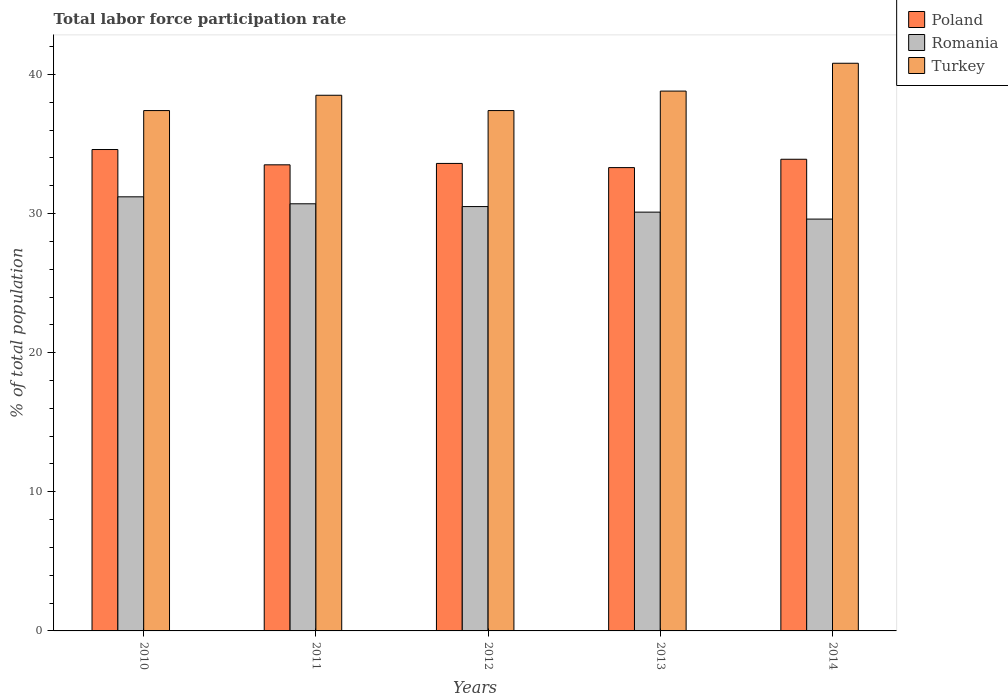How many different coloured bars are there?
Your response must be concise. 3. Are the number of bars per tick equal to the number of legend labels?
Offer a terse response. Yes. How many bars are there on the 5th tick from the left?
Provide a short and direct response. 3. How many bars are there on the 2nd tick from the right?
Your answer should be very brief. 3. What is the label of the 3rd group of bars from the left?
Your answer should be very brief. 2012. What is the total labor force participation rate in Turkey in 2012?
Offer a very short reply. 37.4. Across all years, what is the maximum total labor force participation rate in Poland?
Your answer should be compact. 34.6. Across all years, what is the minimum total labor force participation rate in Romania?
Offer a terse response. 29.6. In which year was the total labor force participation rate in Romania maximum?
Your answer should be very brief. 2010. What is the total total labor force participation rate in Romania in the graph?
Give a very brief answer. 152.1. What is the difference between the total labor force participation rate in Turkey in 2010 and that in 2013?
Offer a terse response. -1.4. What is the difference between the total labor force participation rate in Poland in 2010 and the total labor force participation rate in Romania in 2013?
Your response must be concise. 4.5. What is the average total labor force participation rate in Romania per year?
Offer a very short reply. 30.42. In the year 2013, what is the difference between the total labor force participation rate in Poland and total labor force participation rate in Turkey?
Keep it short and to the point. -5.5. In how many years, is the total labor force participation rate in Poland greater than 18 %?
Provide a short and direct response. 5. What is the ratio of the total labor force participation rate in Romania in 2012 to that in 2014?
Make the answer very short. 1.03. What is the difference between the highest and the second highest total labor force participation rate in Romania?
Your response must be concise. 0.5. What is the difference between the highest and the lowest total labor force participation rate in Romania?
Your response must be concise. 1.6. In how many years, is the total labor force participation rate in Turkey greater than the average total labor force participation rate in Turkey taken over all years?
Your answer should be compact. 2. What does the 2nd bar from the right in 2010 represents?
Make the answer very short. Romania. Is it the case that in every year, the sum of the total labor force participation rate in Poland and total labor force participation rate in Turkey is greater than the total labor force participation rate in Romania?
Your answer should be very brief. Yes. How many years are there in the graph?
Provide a succinct answer. 5. What is the difference between two consecutive major ticks on the Y-axis?
Your answer should be very brief. 10. Are the values on the major ticks of Y-axis written in scientific E-notation?
Keep it short and to the point. No. Where does the legend appear in the graph?
Give a very brief answer. Top right. How are the legend labels stacked?
Offer a terse response. Vertical. What is the title of the graph?
Your response must be concise. Total labor force participation rate. What is the label or title of the X-axis?
Your response must be concise. Years. What is the label or title of the Y-axis?
Provide a short and direct response. % of total population. What is the % of total population in Poland in 2010?
Make the answer very short. 34.6. What is the % of total population of Romania in 2010?
Provide a succinct answer. 31.2. What is the % of total population in Turkey in 2010?
Your response must be concise. 37.4. What is the % of total population in Poland in 2011?
Give a very brief answer. 33.5. What is the % of total population of Romania in 2011?
Your answer should be compact. 30.7. What is the % of total population of Turkey in 2011?
Your answer should be very brief. 38.5. What is the % of total population in Poland in 2012?
Offer a terse response. 33.6. What is the % of total population in Romania in 2012?
Your answer should be very brief. 30.5. What is the % of total population of Turkey in 2012?
Keep it short and to the point. 37.4. What is the % of total population in Poland in 2013?
Offer a very short reply. 33.3. What is the % of total population of Romania in 2013?
Keep it short and to the point. 30.1. What is the % of total population in Turkey in 2013?
Keep it short and to the point. 38.8. What is the % of total population in Poland in 2014?
Provide a succinct answer. 33.9. What is the % of total population of Romania in 2014?
Make the answer very short. 29.6. What is the % of total population in Turkey in 2014?
Offer a very short reply. 40.8. Across all years, what is the maximum % of total population of Poland?
Make the answer very short. 34.6. Across all years, what is the maximum % of total population in Romania?
Your answer should be very brief. 31.2. Across all years, what is the maximum % of total population of Turkey?
Offer a terse response. 40.8. Across all years, what is the minimum % of total population of Poland?
Your response must be concise. 33.3. Across all years, what is the minimum % of total population in Romania?
Make the answer very short. 29.6. Across all years, what is the minimum % of total population of Turkey?
Offer a very short reply. 37.4. What is the total % of total population in Poland in the graph?
Your response must be concise. 168.9. What is the total % of total population of Romania in the graph?
Ensure brevity in your answer.  152.1. What is the total % of total population in Turkey in the graph?
Offer a very short reply. 192.9. What is the difference between the % of total population in Romania in 2010 and that in 2011?
Provide a succinct answer. 0.5. What is the difference between the % of total population of Turkey in 2010 and that in 2011?
Your answer should be compact. -1.1. What is the difference between the % of total population in Romania in 2010 and that in 2012?
Your answer should be compact. 0.7. What is the difference between the % of total population of Poland in 2010 and that in 2013?
Your answer should be very brief. 1.3. What is the difference between the % of total population of Romania in 2010 and that in 2013?
Provide a succinct answer. 1.1. What is the difference between the % of total population in Turkey in 2010 and that in 2013?
Offer a very short reply. -1.4. What is the difference between the % of total population in Turkey in 2010 and that in 2014?
Provide a succinct answer. -3.4. What is the difference between the % of total population of Romania in 2011 and that in 2013?
Provide a succinct answer. 0.6. What is the difference between the % of total population of Turkey in 2011 and that in 2014?
Your response must be concise. -2.3. What is the difference between the % of total population in Poland in 2012 and that in 2013?
Keep it short and to the point. 0.3. What is the difference between the % of total population in Romania in 2012 and that in 2013?
Keep it short and to the point. 0.4. What is the difference between the % of total population in Romania in 2012 and that in 2014?
Provide a succinct answer. 0.9. What is the difference between the % of total population of Poland in 2013 and that in 2014?
Provide a succinct answer. -0.6. What is the difference between the % of total population of Poland in 2010 and the % of total population of Turkey in 2012?
Offer a terse response. -2.8. What is the difference between the % of total population in Romania in 2010 and the % of total population in Turkey in 2013?
Offer a very short reply. -7.6. What is the difference between the % of total population of Poland in 2010 and the % of total population of Turkey in 2014?
Make the answer very short. -6.2. What is the difference between the % of total population in Poland in 2011 and the % of total population in Turkey in 2012?
Offer a terse response. -3.9. What is the difference between the % of total population of Poland in 2011 and the % of total population of Romania in 2013?
Provide a short and direct response. 3.4. What is the difference between the % of total population in Romania in 2011 and the % of total population in Turkey in 2013?
Keep it short and to the point. -8.1. What is the difference between the % of total population of Poland in 2011 and the % of total population of Romania in 2014?
Keep it short and to the point. 3.9. What is the difference between the % of total population of Poland in 2011 and the % of total population of Turkey in 2014?
Your answer should be compact. -7.3. What is the difference between the % of total population in Poland in 2012 and the % of total population in Romania in 2013?
Keep it short and to the point. 3.5. What is the difference between the % of total population in Poland in 2012 and the % of total population in Turkey in 2014?
Offer a very short reply. -7.2. What is the difference between the % of total population of Poland in 2013 and the % of total population of Turkey in 2014?
Give a very brief answer. -7.5. What is the difference between the % of total population in Romania in 2013 and the % of total population in Turkey in 2014?
Ensure brevity in your answer.  -10.7. What is the average % of total population of Poland per year?
Your response must be concise. 33.78. What is the average % of total population of Romania per year?
Offer a terse response. 30.42. What is the average % of total population of Turkey per year?
Offer a terse response. 38.58. In the year 2010, what is the difference between the % of total population in Poland and % of total population in Turkey?
Ensure brevity in your answer.  -2.8. In the year 2010, what is the difference between the % of total population of Romania and % of total population of Turkey?
Offer a very short reply. -6.2. In the year 2011, what is the difference between the % of total population in Poland and % of total population in Turkey?
Your response must be concise. -5. In the year 2011, what is the difference between the % of total population in Romania and % of total population in Turkey?
Your answer should be compact. -7.8. In the year 2012, what is the difference between the % of total population of Poland and % of total population of Romania?
Offer a terse response. 3.1. In the year 2013, what is the difference between the % of total population in Poland and % of total population in Romania?
Ensure brevity in your answer.  3.2. In the year 2013, what is the difference between the % of total population of Poland and % of total population of Turkey?
Your response must be concise. -5.5. In the year 2014, what is the difference between the % of total population in Poland and % of total population in Romania?
Make the answer very short. 4.3. In the year 2014, what is the difference between the % of total population of Poland and % of total population of Turkey?
Provide a short and direct response. -6.9. What is the ratio of the % of total population in Poland in 2010 to that in 2011?
Provide a short and direct response. 1.03. What is the ratio of the % of total population in Romania in 2010 to that in 2011?
Provide a succinct answer. 1.02. What is the ratio of the % of total population of Turkey in 2010 to that in 2011?
Provide a short and direct response. 0.97. What is the ratio of the % of total population in Poland in 2010 to that in 2012?
Give a very brief answer. 1.03. What is the ratio of the % of total population of Poland in 2010 to that in 2013?
Your answer should be compact. 1.04. What is the ratio of the % of total population of Romania in 2010 to that in 2013?
Make the answer very short. 1.04. What is the ratio of the % of total population in Turkey in 2010 to that in 2013?
Your answer should be very brief. 0.96. What is the ratio of the % of total population in Poland in 2010 to that in 2014?
Ensure brevity in your answer.  1.02. What is the ratio of the % of total population in Romania in 2010 to that in 2014?
Provide a short and direct response. 1.05. What is the ratio of the % of total population in Turkey in 2010 to that in 2014?
Your answer should be very brief. 0.92. What is the ratio of the % of total population in Romania in 2011 to that in 2012?
Make the answer very short. 1.01. What is the ratio of the % of total population of Turkey in 2011 to that in 2012?
Offer a very short reply. 1.03. What is the ratio of the % of total population of Romania in 2011 to that in 2013?
Ensure brevity in your answer.  1.02. What is the ratio of the % of total population in Poland in 2011 to that in 2014?
Ensure brevity in your answer.  0.99. What is the ratio of the % of total population in Romania in 2011 to that in 2014?
Provide a succinct answer. 1.04. What is the ratio of the % of total population of Turkey in 2011 to that in 2014?
Make the answer very short. 0.94. What is the ratio of the % of total population of Poland in 2012 to that in 2013?
Your response must be concise. 1.01. What is the ratio of the % of total population in Romania in 2012 to that in 2013?
Give a very brief answer. 1.01. What is the ratio of the % of total population in Turkey in 2012 to that in 2013?
Your answer should be compact. 0.96. What is the ratio of the % of total population in Poland in 2012 to that in 2014?
Your response must be concise. 0.99. What is the ratio of the % of total population of Romania in 2012 to that in 2014?
Your answer should be compact. 1.03. What is the ratio of the % of total population in Poland in 2013 to that in 2014?
Provide a short and direct response. 0.98. What is the ratio of the % of total population of Romania in 2013 to that in 2014?
Provide a short and direct response. 1.02. What is the ratio of the % of total population in Turkey in 2013 to that in 2014?
Offer a very short reply. 0.95. What is the difference between the highest and the second highest % of total population in Poland?
Give a very brief answer. 0.7. What is the difference between the highest and the second highest % of total population in Turkey?
Make the answer very short. 2. What is the difference between the highest and the lowest % of total population of Romania?
Ensure brevity in your answer.  1.6. What is the difference between the highest and the lowest % of total population of Turkey?
Your answer should be very brief. 3.4. 